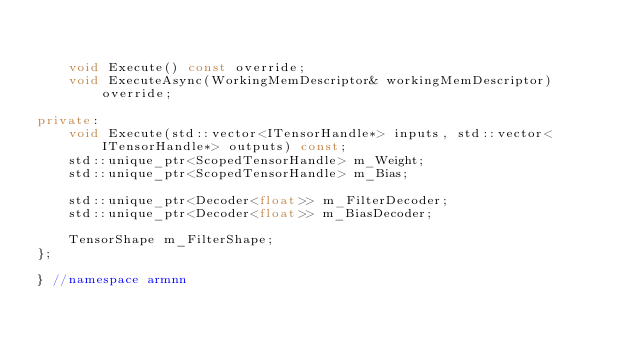<code> <loc_0><loc_0><loc_500><loc_500><_C++_>

    void Execute() const override;
    void ExecuteAsync(WorkingMemDescriptor& workingMemDescriptor)  override;

private:
    void Execute(std::vector<ITensorHandle*> inputs, std::vector<ITensorHandle*> outputs) const;
    std::unique_ptr<ScopedTensorHandle> m_Weight;
    std::unique_ptr<ScopedTensorHandle> m_Bias;

    std::unique_ptr<Decoder<float>> m_FilterDecoder;
    std::unique_ptr<Decoder<float>> m_BiasDecoder;

    TensorShape m_FilterShape;
};

} //namespace armnn

</code> 